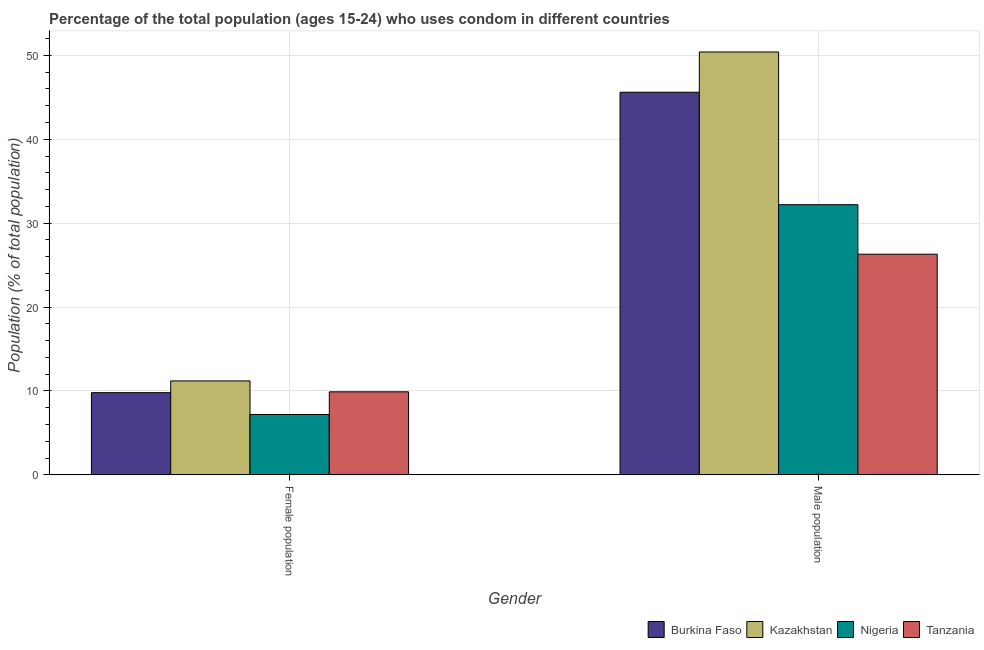How many different coloured bars are there?
Keep it short and to the point. 4. How many groups of bars are there?
Offer a very short reply. 2. How many bars are there on the 2nd tick from the left?
Provide a succinct answer. 4. What is the label of the 1st group of bars from the left?
Keep it short and to the point. Female population. What is the male population in Kazakhstan?
Your answer should be compact. 50.4. Across all countries, what is the minimum female population?
Ensure brevity in your answer.  7.2. In which country was the male population maximum?
Provide a short and direct response. Kazakhstan. In which country was the female population minimum?
Your response must be concise. Nigeria. What is the total female population in the graph?
Offer a terse response. 38.1. What is the difference between the male population in Nigeria and the female population in Tanzania?
Give a very brief answer. 22.3. What is the average female population per country?
Provide a succinct answer. 9.53. What is the difference between the male population and female population in Nigeria?
Give a very brief answer. 25. In how many countries, is the female population greater than 48 %?
Provide a short and direct response. 0. What is the ratio of the female population in Burkina Faso to that in Kazakhstan?
Your answer should be compact. 0.88. Is the female population in Kazakhstan less than that in Nigeria?
Provide a short and direct response. No. What does the 3rd bar from the left in Female population represents?
Provide a short and direct response. Nigeria. What does the 1st bar from the right in Male population represents?
Provide a succinct answer. Tanzania. Are all the bars in the graph horizontal?
Keep it short and to the point. No. How many countries are there in the graph?
Offer a very short reply. 4. What is the difference between two consecutive major ticks on the Y-axis?
Make the answer very short. 10. Does the graph contain grids?
Offer a terse response. Yes. Where does the legend appear in the graph?
Offer a very short reply. Bottom right. How many legend labels are there?
Make the answer very short. 4. How are the legend labels stacked?
Offer a terse response. Horizontal. What is the title of the graph?
Offer a very short reply. Percentage of the total population (ages 15-24) who uses condom in different countries. What is the label or title of the Y-axis?
Ensure brevity in your answer.  Population (% of total population) . What is the Population (% of total population)  of Burkina Faso in Female population?
Make the answer very short. 9.8. What is the Population (% of total population)  of Tanzania in Female population?
Offer a very short reply. 9.9. What is the Population (% of total population)  in Burkina Faso in Male population?
Your answer should be compact. 45.6. What is the Population (% of total population)  of Kazakhstan in Male population?
Your answer should be compact. 50.4. What is the Population (% of total population)  of Nigeria in Male population?
Offer a terse response. 32.2. What is the Population (% of total population)  of Tanzania in Male population?
Ensure brevity in your answer.  26.3. Across all Gender, what is the maximum Population (% of total population)  in Burkina Faso?
Offer a terse response. 45.6. Across all Gender, what is the maximum Population (% of total population)  of Kazakhstan?
Give a very brief answer. 50.4. Across all Gender, what is the maximum Population (% of total population)  in Nigeria?
Ensure brevity in your answer.  32.2. Across all Gender, what is the maximum Population (% of total population)  in Tanzania?
Offer a terse response. 26.3. Across all Gender, what is the minimum Population (% of total population)  of Nigeria?
Offer a very short reply. 7.2. What is the total Population (% of total population)  in Burkina Faso in the graph?
Give a very brief answer. 55.4. What is the total Population (% of total population)  of Kazakhstan in the graph?
Provide a short and direct response. 61.6. What is the total Population (% of total population)  in Nigeria in the graph?
Make the answer very short. 39.4. What is the total Population (% of total population)  of Tanzania in the graph?
Your response must be concise. 36.2. What is the difference between the Population (% of total population)  in Burkina Faso in Female population and that in Male population?
Offer a terse response. -35.8. What is the difference between the Population (% of total population)  of Kazakhstan in Female population and that in Male population?
Your answer should be compact. -39.2. What is the difference between the Population (% of total population)  of Tanzania in Female population and that in Male population?
Your response must be concise. -16.4. What is the difference between the Population (% of total population)  of Burkina Faso in Female population and the Population (% of total population)  of Kazakhstan in Male population?
Give a very brief answer. -40.6. What is the difference between the Population (% of total population)  in Burkina Faso in Female population and the Population (% of total population)  in Nigeria in Male population?
Provide a short and direct response. -22.4. What is the difference between the Population (% of total population)  of Burkina Faso in Female population and the Population (% of total population)  of Tanzania in Male population?
Make the answer very short. -16.5. What is the difference between the Population (% of total population)  in Kazakhstan in Female population and the Population (% of total population)  in Tanzania in Male population?
Provide a succinct answer. -15.1. What is the difference between the Population (% of total population)  in Nigeria in Female population and the Population (% of total population)  in Tanzania in Male population?
Your answer should be compact. -19.1. What is the average Population (% of total population)  of Burkina Faso per Gender?
Give a very brief answer. 27.7. What is the average Population (% of total population)  of Kazakhstan per Gender?
Ensure brevity in your answer.  30.8. What is the average Population (% of total population)  of Tanzania per Gender?
Offer a very short reply. 18.1. What is the difference between the Population (% of total population)  in Burkina Faso and Population (% of total population)  in Kazakhstan in Female population?
Your answer should be compact. -1.4. What is the difference between the Population (% of total population)  in Kazakhstan and Population (% of total population)  in Nigeria in Female population?
Give a very brief answer. 4. What is the difference between the Population (% of total population)  in Burkina Faso and Population (% of total population)  in Nigeria in Male population?
Offer a terse response. 13.4. What is the difference between the Population (% of total population)  of Burkina Faso and Population (% of total population)  of Tanzania in Male population?
Ensure brevity in your answer.  19.3. What is the difference between the Population (% of total population)  in Kazakhstan and Population (% of total population)  in Tanzania in Male population?
Provide a short and direct response. 24.1. What is the difference between the Population (% of total population)  of Nigeria and Population (% of total population)  of Tanzania in Male population?
Offer a terse response. 5.9. What is the ratio of the Population (% of total population)  in Burkina Faso in Female population to that in Male population?
Your answer should be very brief. 0.21. What is the ratio of the Population (% of total population)  of Kazakhstan in Female population to that in Male population?
Ensure brevity in your answer.  0.22. What is the ratio of the Population (% of total population)  of Nigeria in Female population to that in Male population?
Ensure brevity in your answer.  0.22. What is the ratio of the Population (% of total population)  in Tanzania in Female population to that in Male population?
Your answer should be compact. 0.38. What is the difference between the highest and the second highest Population (% of total population)  in Burkina Faso?
Make the answer very short. 35.8. What is the difference between the highest and the second highest Population (% of total population)  of Kazakhstan?
Ensure brevity in your answer.  39.2. What is the difference between the highest and the second highest Population (% of total population)  of Nigeria?
Your response must be concise. 25. What is the difference between the highest and the lowest Population (% of total population)  in Burkina Faso?
Your response must be concise. 35.8. What is the difference between the highest and the lowest Population (% of total population)  in Kazakhstan?
Your answer should be very brief. 39.2. What is the difference between the highest and the lowest Population (% of total population)  in Tanzania?
Offer a very short reply. 16.4. 